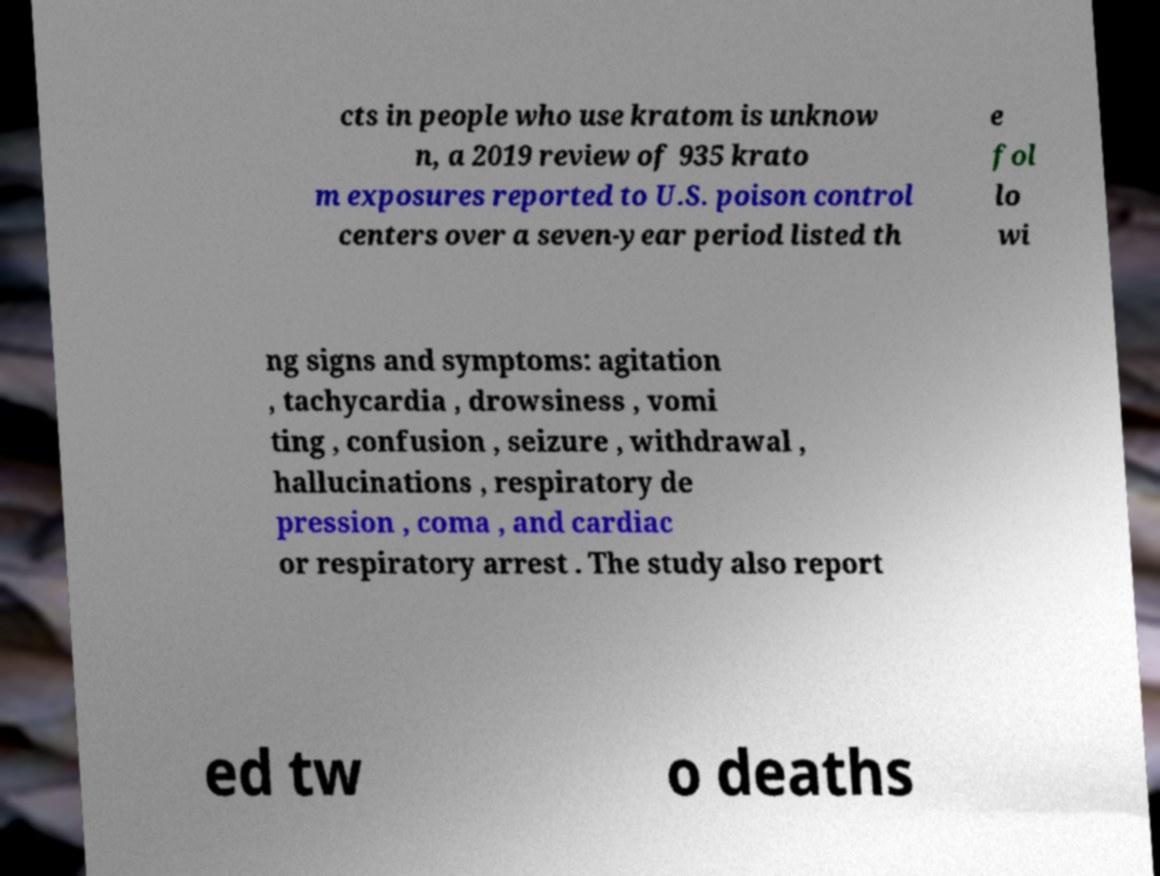Could you extract and type out the text from this image? cts in people who use kratom is unknow n, a 2019 review of 935 krato m exposures reported to U.S. poison control centers over a seven-year period listed th e fol lo wi ng signs and symptoms: agitation , tachycardia , drowsiness , vomi ting , confusion , seizure , withdrawal , hallucinations , respiratory de pression , coma , and cardiac or respiratory arrest . The study also report ed tw o deaths 